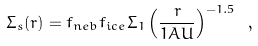<formula> <loc_0><loc_0><loc_500><loc_500>\Sigma _ { s } ( r ) = f _ { n e b } f _ { i c e } \Sigma _ { 1 } \left ( \frac { r } { 1 A U } \right ) ^ { - 1 . 5 } \ ,</formula> 